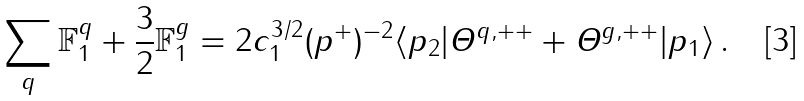<formula> <loc_0><loc_0><loc_500><loc_500>\sum _ { q } \mathbb { F } _ { 1 } ^ { q } + \frac { 3 } { 2 } \mathbb { F } _ { 1 } ^ { g } = 2 c _ { 1 } ^ { 3 / 2 } ( p ^ { + } ) ^ { - 2 } \langle p _ { 2 } | { \mathit \Theta } ^ { q , + + } + { \mathit \Theta } ^ { g , + + } | p _ { 1 } \rangle \, .</formula> 